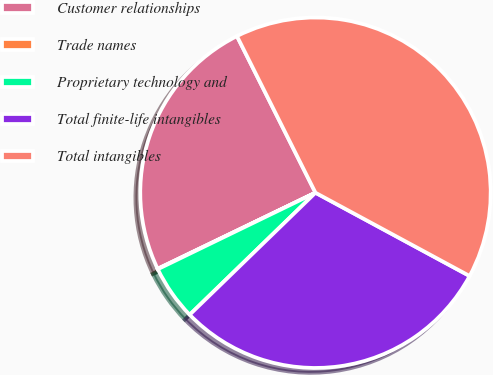<chart> <loc_0><loc_0><loc_500><loc_500><pie_chart><fcel>Customer relationships<fcel>Trade names<fcel>Proprietary technology and<fcel>Total finite-life intangibles<fcel>Total intangibles<nl><fcel>24.75%<fcel>0.04%<fcel>5.07%<fcel>29.86%<fcel>40.28%<nl></chart> 